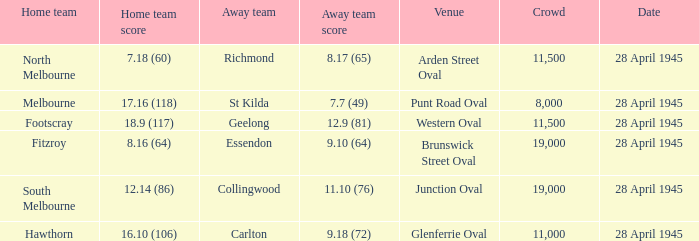14 (86)? 11.10 (76). 